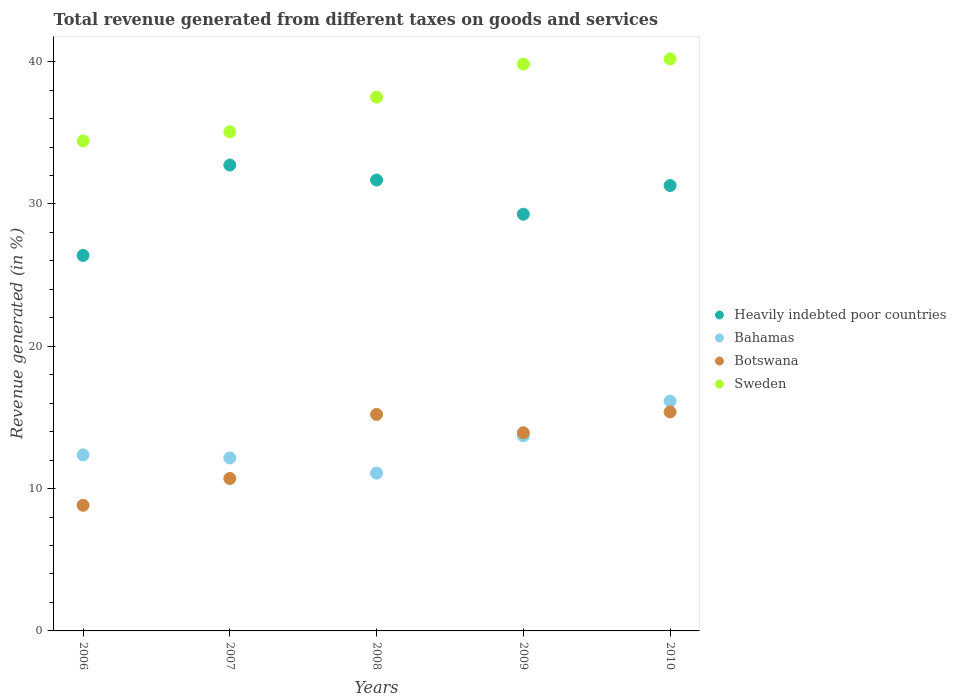How many different coloured dotlines are there?
Give a very brief answer. 4. Is the number of dotlines equal to the number of legend labels?
Make the answer very short. Yes. What is the total revenue generated in Botswana in 2008?
Provide a short and direct response. 15.21. Across all years, what is the maximum total revenue generated in Heavily indebted poor countries?
Provide a short and direct response. 32.74. Across all years, what is the minimum total revenue generated in Sweden?
Your answer should be compact. 34.43. What is the total total revenue generated in Botswana in the graph?
Keep it short and to the point. 64.07. What is the difference between the total revenue generated in Sweden in 2006 and that in 2010?
Provide a short and direct response. -5.76. What is the difference between the total revenue generated in Sweden in 2006 and the total revenue generated in Heavily indebted poor countries in 2009?
Provide a succinct answer. 5.15. What is the average total revenue generated in Sweden per year?
Your answer should be very brief. 37.41. In the year 2010, what is the difference between the total revenue generated in Sweden and total revenue generated in Bahamas?
Provide a succinct answer. 24.05. In how many years, is the total revenue generated in Botswana greater than 2 %?
Give a very brief answer. 5. What is the ratio of the total revenue generated in Sweden in 2007 to that in 2009?
Provide a short and direct response. 0.88. What is the difference between the highest and the second highest total revenue generated in Sweden?
Your answer should be compact. 0.37. What is the difference between the highest and the lowest total revenue generated in Sweden?
Provide a short and direct response. 5.76. In how many years, is the total revenue generated in Botswana greater than the average total revenue generated in Botswana taken over all years?
Provide a short and direct response. 3. Is the sum of the total revenue generated in Sweden in 2006 and 2007 greater than the maximum total revenue generated in Heavily indebted poor countries across all years?
Ensure brevity in your answer.  Yes. Is it the case that in every year, the sum of the total revenue generated in Heavily indebted poor countries and total revenue generated in Bahamas  is greater than the sum of total revenue generated in Botswana and total revenue generated in Sweden?
Your response must be concise. Yes. Is it the case that in every year, the sum of the total revenue generated in Sweden and total revenue generated in Heavily indebted poor countries  is greater than the total revenue generated in Botswana?
Offer a terse response. Yes. Does the total revenue generated in Heavily indebted poor countries monotonically increase over the years?
Offer a terse response. No. How many years are there in the graph?
Make the answer very short. 5. Does the graph contain any zero values?
Your response must be concise. No. Does the graph contain grids?
Your answer should be very brief. No. Where does the legend appear in the graph?
Keep it short and to the point. Center right. What is the title of the graph?
Offer a terse response. Total revenue generated from different taxes on goods and services. What is the label or title of the Y-axis?
Offer a terse response. Revenue generated (in %). What is the Revenue generated (in %) of Heavily indebted poor countries in 2006?
Provide a succinct answer. 26.38. What is the Revenue generated (in %) in Bahamas in 2006?
Offer a terse response. 12.37. What is the Revenue generated (in %) in Botswana in 2006?
Keep it short and to the point. 8.83. What is the Revenue generated (in %) in Sweden in 2006?
Your answer should be compact. 34.43. What is the Revenue generated (in %) in Heavily indebted poor countries in 2007?
Your answer should be compact. 32.74. What is the Revenue generated (in %) of Bahamas in 2007?
Provide a short and direct response. 12.16. What is the Revenue generated (in %) in Botswana in 2007?
Ensure brevity in your answer.  10.71. What is the Revenue generated (in %) of Sweden in 2007?
Give a very brief answer. 35.07. What is the Revenue generated (in %) in Heavily indebted poor countries in 2008?
Keep it short and to the point. 31.68. What is the Revenue generated (in %) in Bahamas in 2008?
Ensure brevity in your answer.  11.09. What is the Revenue generated (in %) of Botswana in 2008?
Your response must be concise. 15.21. What is the Revenue generated (in %) in Sweden in 2008?
Give a very brief answer. 37.51. What is the Revenue generated (in %) of Heavily indebted poor countries in 2009?
Offer a terse response. 29.28. What is the Revenue generated (in %) in Bahamas in 2009?
Give a very brief answer. 13.71. What is the Revenue generated (in %) of Botswana in 2009?
Provide a succinct answer. 13.92. What is the Revenue generated (in %) of Sweden in 2009?
Offer a very short reply. 39.83. What is the Revenue generated (in %) in Heavily indebted poor countries in 2010?
Provide a succinct answer. 31.3. What is the Revenue generated (in %) in Bahamas in 2010?
Ensure brevity in your answer.  16.15. What is the Revenue generated (in %) in Botswana in 2010?
Your response must be concise. 15.39. What is the Revenue generated (in %) in Sweden in 2010?
Your answer should be compact. 40.2. Across all years, what is the maximum Revenue generated (in %) in Heavily indebted poor countries?
Your answer should be compact. 32.74. Across all years, what is the maximum Revenue generated (in %) of Bahamas?
Keep it short and to the point. 16.15. Across all years, what is the maximum Revenue generated (in %) in Botswana?
Provide a succinct answer. 15.39. Across all years, what is the maximum Revenue generated (in %) of Sweden?
Give a very brief answer. 40.2. Across all years, what is the minimum Revenue generated (in %) in Heavily indebted poor countries?
Provide a succinct answer. 26.38. Across all years, what is the minimum Revenue generated (in %) in Bahamas?
Your answer should be very brief. 11.09. Across all years, what is the minimum Revenue generated (in %) of Botswana?
Give a very brief answer. 8.83. Across all years, what is the minimum Revenue generated (in %) in Sweden?
Give a very brief answer. 34.43. What is the total Revenue generated (in %) in Heavily indebted poor countries in the graph?
Your answer should be very brief. 151.38. What is the total Revenue generated (in %) in Bahamas in the graph?
Your answer should be very brief. 65.47. What is the total Revenue generated (in %) in Botswana in the graph?
Your response must be concise. 64.07. What is the total Revenue generated (in %) of Sweden in the graph?
Make the answer very short. 187.04. What is the difference between the Revenue generated (in %) of Heavily indebted poor countries in 2006 and that in 2007?
Your answer should be compact. -6.35. What is the difference between the Revenue generated (in %) of Bahamas in 2006 and that in 2007?
Provide a succinct answer. 0.21. What is the difference between the Revenue generated (in %) in Botswana in 2006 and that in 2007?
Your answer should be compact. -1.88. What is the difference between the Revenue generated (in %) in Sweden in 2006 and that in 2007?
Make the answer very short. -0.64. What is the difference between the Revenue generated (in %) of Heavily indebted poor countries in 2006 and that in 2008?
Make the answer very short. -5.3. What is the difference between the Revenue generated (in %) in Bahamas in 2006 and that in 2008?
Your answer should be compact. 1.28. What is the difference between the Revenue generated (in %) in Botswana in 2006 and that in 2008?
Offer a terse response. -6.38. What is the difference between the Revenue generated (in %) in Sweden in 2006 and that in 2008?
Your response must be concise. -3.07. What is the difference between the Revenue generated (in %) of Heavily indebted poor countries in 2006 and that in 2009?
Offer a terse response. -2.9. What is the difference between the Revenue generated (in %) of Bahamas in 2006 and that in 2009?
Offer a very short reply. -1.34. What is the difference between the Revenue generated (in %) in Botswana in 2006 and that in 2009?
Make the answer very short. -5.09. What is the difference between the Revenue generated (in %) in Sweden in 2006 and that in 2009?
Your response must be concise. -5.39. What is the difference between the Revenue generated (in %) in Heavily indebted poor countries in 2006 and that in 2010?
Offer a very short reply. -4.91. What is the difference between the Revenue generated (in %) in Bahamas in 2006 and that in 2010?
Your answer should be very brief. -3.78. What is the difference between the Revenue generated (in %) in Botswana in 2006 and that in 2010?
Your response must be concise. -6.56. What is the difference between the Revenue generated (in %) of Sweden in 2006 and that in 2010?
Offer a very short reply. -5.76. What is the difference between the Revenue generated (in %) of Heavily indebted poor countries in 2007 and that in 2008?
Provide a short and direct response. 1.05. What is the difference between the Revenue generated (in %) in Bahamas in 2007 and that in 2008?
Keep it short and to the point. 1.07. What is the difference between the Revenue generated (in %) in Botswana in 2007 and that in 2008?
Keep it short and to the point. -4.5. What is the difference between the Revenue generated (in %) in Sweden in 2007 and that in 2008?
Offer a very short reply. -2.44. What is the difference between the Revenue generated (in %) of Heavily indebted poor countries in 2007 and that in 2009?
Ensure brevity in your answer.  3.46. What is the difference between the Revenue generated (in %) of Bahamas in 2007 and that in 2009?
Your response must be concise. -1.55. What is the difference between the Revenue generated (in %) in Botswana in 2007 and that in 2009?
Your response must be concise. -3.21. What is the difference between the Revenue generated (in %) in Sweden in 2007 and that in 2009?
Offer a very short reply. -4.76. What is the difference between the Revenue generated (in %) in Heavily indebted poor countries in 2007 and that in 2010?
Your answer should be compact. 1.44. What is the difference between the Revenue generated (in %) in Bahamas in 2007 and that in 2010?
Offer a very short reply. -3.99. What is the difference between the Revenue generated (in %) of Botswana in 2007 and that in 2010?
Keep it short and to the point. -4.68. What is the difference between the Revenue generated (in %) of Sweden in 2007 and that in 2010?
Ensure brevity in your answer.  -5.12. What is the difference between the Revenue generated (in %) in Heavily indebted poor countries in 2008 and that in 2009?
Give a very brief answer. 2.4. What is the difference between the Revenue generated (in %) in Bahamas in 2008 and that in 2009?
Offer a very short reply. -2.62. What is the difference between the Revenue generated (in %) in Botswana in 2008 and that in 2009?
Your answer should be very brief. 1.29. What is the difference between the Revenue generated (in %) of Sweden in 2008 and that in 2009?
Make the answer very short. -2.32. What is the difference between the Revenue generated (in %) in Heavily indebted poor countries in 2008 and that in 2010?
Provide a short and direct response. 0.39. What is the difference between the Revenue generated (in %) of Bahamas in 2008 and that in 2010?
Offer a terse response. -5.06. What is the difference between the Revenue generated (in %) in Botswana in 2008 and that in 2010?
Offer a very short reply. -0.17. What is the difference between the Revenue generated (in %) of Sweden in 2008 and that in 2010?
Offer a terse response. -2.69. What is the difference between the Revenue generated (in %) of Heavily indebted poor countries in 2009 and that in 2010?
Keep it short and to the point. -2.02. What is the difference between the Revenue generated (in %) in Bahamas in 2009 and that in 2010?
Offer a very short reply. -2.44. What is the difference between the Revenue generated (in %) of Botswana in 2009 and that in 2010?
Provide a short and direct response. -1.46. What is the difference between the Revenue generated (in %) of Sweden in 2009 and that in 2010?
Provide a short and direct response. -0.37. What is the difference between the Revenue generated (in %) of Heavily indebted poor countries in 2006 and the Revenue generated (in %) of Bahamas in 2007?
Offer a very short reply. 14.23. What is the difference between the Revenue generated (in %) in Heavily indebted poor countries in 2006 and the Revenue generated (in %) in Botswana in 2007?
Offer a terse response. 15.67. What is the difference between the Revenue generated (in %) of Heavily indebted poor countries in 2006 and the Revenue generated (in %) of Sweden in 2007?
Ensure brevity in your answer.  -8.69. What is the difference between the Revenue generated (in %) in Bahamas in 2006 and the Revenue generated (in %) in Botswana in 2007?
Offer a very short reply. 1.66. What is the difference between the Revenue generated (in %) in Bahamas in 2006 and the Revenue generated (in %) in Sweden in 2007?
Your answer should be compact. -22.7. What is the difference between the Revenue generated (in %) in Botswana in 2006 and the Revenue generated (in %) in Sweden in 2007?
Offer a terse response. -26.24. What is the difference between the Revenue generated (in %) of Heavily indebted poor countries in 2006 and the Revenue generated (in %) of Bahamas in 2008?
Give a very brief answer. 15.3. What is the difference between the Revenue generated (in %) of Heavily indebted poor countries in 2006 and the Revenue generated (in %) of Botswana in 2008?
Keep it short and to the point. 11.17. What is the difference between the Revenue generated (in %) in Heavily indebted poor countries in 2006 and the Revenue generated (in %) in Sweden in 2008?
Ensure brevity in your answer.  -11.12. What is the difference between the Revenue generated (in %) of Bahamas in 2006 and the Revenue generated (in %) of Botswana in 2008?
Provide a short and direct response. -2.84. What is the difference between the Revenue generated (in %) in Bahamas in 2006 and the Revenue generated (in %) in Sweden in 2008?
Offer a terse response. -25.14. What is the difference between the Revenue generated (in %) in Botswana in 2006 and the Revenue generated (in %) in Sweden in 2008?
Offer a terse response. -28.68. What is the difference between the Revenue generated (in %) in Heavily indebted poor countries in 2006 and the Revenue generated (in %) in Bahamas in 2009?
Make the answer very short. 12.68. What is the difference between the Revenue generated (in %) of Heavily indebted poor countries in 2006 and the Revenue generated (in %) of Botswana in 2009?
Provide a succinct answer. 12.46. What is the difference between the Revenue generated (in %) in Heavily indebted poor countries in 2006 and the Revenue generated (in %) in Sweden in 2009?
Your response must be concise. -13.44. What is the difference between the Revenue generated (in %) of Bahamas in 2006 and the Revenue generated (in %) of Botswana in 2009?
Your response must be concise. -1.55. What is the difference between the Revenue generated (in %) of Bahamas in 2006 and the Revenue generated (in %) of Sweden in 2009?
Make the answer very short. -27.46. What is the difference between the Revenue generated (in %) in Botswana in 2006 and the Revenue generated (in %) in Sweden in 2009?
Keep it short and to the point. -31. What is the difference between the Revenue generated (in %) of Heavily indebted poor countries in 2006 and the Revenue generated (in %) of Bahamas in 2010?
Offer a very short reply. 10.24. What is the difference between the Revenue generated (in %) of Heavily indebted poor countries in 2006 and the Revenue generated (in %) of Botswana in 2010?
Your answer should be very brief. 11. What is the difference between the Revenue generated (in %) of Heavily indebted poor countries in 2006 and the Revenue generated (in %) of Sweden in 2010?
Offer a terse response. -13.81. What is the difference between the Revenue generated (in %) in Bahamas in 2006 and the Revenue generated (in %) in Botswana in 2010?
Give a very brief answer. -3.02. What is the difference between the Revenue generated (in %) in Bahamas in 2006 and the Revenue generated (in %) in Sweden in 2010?
Keep it short and to the point. -27.83. What is the difference between the Revenue generated (in %) in Botswana in 2006 and the Revenue generated (in %) in Sweden in 2010?
Offer a terse response. -31.37. What is the difference between the Revenue generated (in %) in Heavily indebted poor countries in 2007 and the Revenue generated (in %) in Bahamas in 2008?
Your response must be concise. 21.65. What is the difference between the Revenue generated (in %) of Heavily indebted poor countries in 2007 and the Revenue generated (in %) of Botswana in 2008?
Provide a short and direct response. 17.52. What is the difference between the Revenue generated (in %) of Heavily indebted poor countries in 2007 and the Revenue generated (in %) of Sweden in 2008?
Provide a succinct answer. -4.77. What is the difference between the Revenue generated (in %) of Bahamas in 2007 and the Revenue generated (in %) of Botswana in 2008?
Your answer should be compact. -3.06. What is the difference between the Revenue generated (in %) of Bahamas in 2007 and the Revenue generated (in %) of Sweden in 2008?
Your response must be concise. -25.35. What is the difference between the Revenue generated (in %) of Botswana in 2007 and the Revenue generated (in %) of Sweden in 2008?
Your answer should be compact. -26.8. What is the difference between the Revenue generated (in %) of Heavily indebted poor countries in 2007 and the Revenue generated (in %) of Bahamas in 2009?
Ensure brevity in your answer.  19.03. What is the difference between the Revenue generated (in %) of Heavily indebted poor countries in 2007 and the Revenue generated (in %) of Botswana in 2009?
Make the answer very short. 18.81. What is the difference between the Revenue generated (in %) in Heavily indebted poor countries in 2007 and the Revenue generated (in %) in Sweden in 2009?
Offer a very short reply. -7.09. What is the difference between the Revenue generated (in %) of Bahamas in 2007 and the Revenue generated (in %) of Botswana in 2009?
Offer a terse response. -1.77. What is the difference between the Revenue generated (in %) of Bahamas in 2007 and the Revenue generated (in %) of Sweden in 2009?
Provide a short and direct response. -27.67. What is the difference between the Revenue generated (in %) of Botswana in 2007 and the Revenue generated (in %) of Sweden in 2009?
Make the answer very short. -29.12. What is the difference between the Revenue generated (in %) of Heavily indebted poor countries in 2007 and the Revenue generated (in %) of Bahamas in 2010?
Make the answer very short. 16.59. What is the difference between the Revenue generated (in %) of Heavily indebted poor countries in 2007 and the Revenue generated (in %) of Botswana in 2010?
Make the answer very short. 17.35. What is the difference between the Revenue generated (in %) of Heavily indebted poor countries in 2007 and the Revenue generated (in %) of Sweden in 2010?
Give a very brief answer. -7.46. What is the difference between the Revenue generated (in %) in Bahamas in 2007 and the Revenue generated (in %) in Botswana in 2010?
Your response must be concise. -3.23. What is the difference between the Revenue generated (in %) in Bahamas in 2007 and the Revenue generated (in %) in Sweden in 2010?
Provide a short and direct response. -28.04. What is the difference between the Revenue generated (in %) of Botswana in 2007 and the Revenue generated (in %) of Sweden in 2010?
Your answer should be compact. -29.48. What is the difference between the Revenue generated (in %) of Heavily indebted poor countries in 2008 and the Revenue generated (in %) of Bahamas in 2009?
Give a very brief answer. 17.97. What is the difference between the Revenue generated (in %) in Heavily indebted poor countries in 2008 and the Revenue generated (in %) in Botswana in 2009?
Keep it short and to the point. 17.76. What is the difference between the Revenue generated (in %) in Heavily indebted poor countries in 2008 and the Revenue generated (in %) in Sweden in 2009?
Keep it short and to the point. -8.15. What is the difference between the Revenue generated (in %) of Bahamas in 2008 and the Revenue generated (in %) of Botswana in 2009?
Your answer should be compact. -2.84. What is the difference between the Revenue generated (in %) in Bahamas in 2008 and the Revenue generated (in %) in Sweden in 2009?
Ensure brevity in your answer.  -28.74. What is the difference between the Revenue generated (in %) in Botswana in 2008 and the Revenue generated (in %) in Sweden in 2009?
Provide a succinct answer. -24.62. What is the difference between the Revenue generated (in %) of Heavily indebted poor countries in 2008 and the Revenue generated (in %) of Bahamas in 2010?
Give a very brief answer. 15.54. What is the difference between the Revenue generated (in %) of Heavily indebted poor countries in 2008 and the Revenue generated (in %) of Botswana in 2010?
Your answer should be very brief. 16.3. What is the difference between the Revenue generated (in %) in Heavily indebted poor countries in 2008 and the Revenue generated (in %) in Sweden in 2010?
Your response must be concise. -8.51. What is the difference between the Revenue generated (in %) in Bahamas in 2008 and the Revenue generated (in %) in Botswana in 2010?
Keep it short and to the point. -4.3. What is the difference between the Revenue generated (in %) in Bahamas in 2008 and the Revenue generated (in %) in Sweden in 2010?
Make the answer very short. -29.11. What is the difference between the Revenue generated (in %) in Botswana in 2008 and the Revenue generated (in %) in Sweden in 2010?
Your response must be concise. -24.98. What is the difference between the Revenue generated (in %) in Heavily indebted poor countries in 2009 and the Revenue generated (in %) in Bahamas in 2010?
Your response must be concise. 13.13. What is the difference between the Revenue generated (in %) of Heavily indebted poor countries in 2009 and the Revenue generated (in %) of Botswana in 2010?
Offer a very short reply. 13.89. What is the difference between the Revenue generated (in %) of Heavily indebted poor countries in 2009 and the Revenue generated (in %) of Sweden in 2010?
Your answer should be compact. -10.91. What is the difference between the Revenue generated (in %) in Bahamas in 2009 and the Revenue generated (in %) in Botswana in 2010?
Ensure brevity in your answer.  -1.68. What is the difference between the Revenue generated (in %) in Bahamas in 2009 and the Revenue generated (in %) in Sweden in 2010?
Your answer should be compact. -26.49. What is the difference between the Revenue generated (in %) of Botswana in 2009 and the Revenue generated (in %) of Sweden in 2010?
Your answer should be compact. -26.27. What is the average Revenue generated (in %) in Heavily indebted poor countries per year?
Ensure brevity in your answer.  30.28. What is the average Revenue generated (in %) of Bahamas per year?
Give a very brief answer. 13.09. What is the average Revenue generated (in %) in Botswana per year?
Make the answer very short. 12.81. What is the average Revenue generated (in %) of Sweden per year?
Ensure brevity in your answer.  37.41. In the year 2006, what is the difference between the Revenue generated (in %) of Heavily indebted poor countries and Revenue generated (in %) of Bahamas?
Provide a succinct answer. 14.02. In the year 2006, what is the difference between the Revenue generated (in %) of Heavily indebted poor countries and Revenue generated (in %) of Botswana?
Make the answer very short. 17.56. In the year 2006, what is the difference between the Revenue generated (in %) in Heavily indebted poor countries and Revenue generated (in %) in Sweden?
Ensure brevity in your answer.  -8.05. In the year 2006, what is the difference between the Revenue generated (in %) in Bahamas and Revenue generated (in %) in Botswana?
Keep it short and to the point. 3.54. In the year 2006, what is the difference between the Revenue generated (in %) in Bahamas and Revenue generated (in %) in Sweden?
Make the answer very short. -22.06. In the year 2006, what is the difference between the Revenue generated (in %) in Botswana and Revenue generated (in %) in Sweden?
Your answer should be compact. -25.61. In the year 2007, what is the difference between the Revenue generated (in %) in Heavily indebted poor countries and Revenue generated (in %) in Bahamas?
Offer a terse response. 20.58. In the year 2007, what is the difference between the Revenue generated (in %) of Heavily indebted poor countries and Revenue generated (in %) of Botswana?
Keep it short and to the point. 22.03. In the year 2007, what is the difference between the Revenue generated (in %) of Heavily indebted poor countries and Revenue generated (in %) of Sweden?
Provide a succinct answer. -2.33. In the year 2007, what is the difference between the Revenue generated (in %) in Bahamas and Revenue generated (in %) in Botswana?
Offer a very short reply. 1.44. In the year 2007, what is the difference between the Revenue generated (in %) in Bahamas and Revenue generated (in %) in Sweden?
Offer a very short reply. -22.92. In the year 2007, what is the difference between the Revenue generated (in %) of Botswana and Revenue generated (in %) of Sweden?
Your answer should be very brief. -24.36. In the year 2008, what is the difference between the Revenue generated (in %) in Heavily indebted poor countries and Revenue generated (in %) in Bahamas?
Offer a very short reply. 20.6. In the year 2008, what is the difference between the Revenue generated (in %) in Heavily indebted poor countries and Revenue generated (in %) in Botswana?
Keep it short and to the point. 16.47. In the year 2008, what is the difference between the Revenue generated (in %) in Heavily indebted poor countries and Revenue generated (in %) in Sweden?
Your response must be concise. -5.83. In the year 2008, what is the difference between the Revenue generated (in %) in Bahamas and Revenue generated (in %) in Botswana?
Keep it short and to the point. -4.13. In the year 2008, what is the difference between the Revenue generated (in %) of Bahamas and Revenue generated (in %) of Sweden?
Your answer should be very brief. -26.42. In the year 2008, what is the difference between the Revenue generated (in %) in Botswana and Revenue generated (in %) in Sweden?
Your response must be concise. -22.29. In the year 2009, what is the difference between the Revenue generated (in %) of Heavily indebted poor countries and Revenue generated (in %) of Bahamas?
Provide a succinct answer. 15.57. In the year 2009, what is the difference between the Revenue generated (in %) of Heavily indebted poor countries and Revenue generated (in %) of Botswana?
Offer a terse response. 15.36. In the year 2009, what is the difference between the Revenue generated (in %) of Heavily indebted poor countries and Revenue generated (in %) of Sweden?
Your answer should be compact. -10.55. In the year 2009, what is the difference between the Revenue generated (in %) of Bahamas and Revenue generated (in %) of Botswana?
Your answer should be compact. -0.21. In the year 2009, what is the difference between the Revenue generated (in %) of Bahamas and Revenue generated (in %) of Sweden?
Offer a terse response. -26.12. In the year 2009, what is the difference between the Revenue generated (in %) in Botswana and Revenue generated (in %) in Sweden?
Provide a short and direct response. -25.91. In the year 2010, what is the difference between the Revenue generated (in %) of Heavily indebted poor countries and Revenue generated (in %) of Bahamas?
Your answer should be compact. 15.15. In the year 2010, what is the difference between the Revenue generated (in %) in Heavily indebted poor countries and Revenue generated (in %) in Botswana?
Make the answer very short. 15.91. In the year 2010, what is the difference between the Revenue generated (in %) in Heavily indebted poor countries and Revenue generated (in %) in Sweden?
Keep it short and to the point. -8.9. In the year 2010, what is the difference between the Revenue generated (in %) in Bahamas and Revenue generated (in %) in Botswana?
Offer a terse response. 0.76. In the year 2010, what is the difference between the Revenue generated (in %) of Bahamas and Revenue generated (in %) of Sweden?
Your response must be concise. -24.05. In the year 2010, what is the difference between the Revenue generated (in %) of Botswana and Revenue generated (in %) of Sweden?
Your answer should be compact. -24.81. What is the ratio of the Revenue generated (in %) of Heavily indebted poor countries in 2006 to that in 2007?
Offer a terse response. 0.81. What is the ratio of the Revenue generated (in %) of Bahamas in 2006 to that in 2007?
Make the answer very short. 1.02. What is the ratio of the Revenue generated (in %) in Botswana in 2006 to that in 2007?
Give a very brief answer. 0.82. What is the ratio of the Revenue generated (in %) of Sweden in 2006 to that in 2007?
Make the answer very short. 0.98. What is the ratio of the Revenue generated (in %) of Heavily indebted poor countries in 2006 to that in 2008?
Your answer should be compact. 0.83. What is the ratio of the Revenue generated (in %) of Bahamas in 2006 to that in 2008?
Make the answer very short. 1.12. What is the ratio of the Revenue generated (in %) of Botswana in 2006 to that in 2008?
Your answer should be compact. 0.58. What is the ratio of the Revenue generated (in %) of Sweden in 2006 to that in 2008?
Your answer should be very brief. 0.92. What is the ratio of the Revenue generated (in %) in Heavily indebted poor countries in 2006 to that in 2009?
Give a very brief answer. 0.9. What is the ratio of the Revenue generated (in %) of Bahamas in 2006 to that in 2009?
Your answer should be compact. 0.9. What is the ratio of the Revenue generated (in %) of Botswana in 2006 to that in 2009?
Your answer should be compact. 0.63. What is the ratio of the Revenue generated (in %) of Sweden in 2006 to that in 2009?
Your answer should be very brief. 0.86. What is the ratio of the Revenue generated (in %) in Heavily indebted poor countries in 2006 to that in 2010?
Your answer should be very brief. 0.84. What is the ratio of the Revenue generated (in %) of Bahamas in 2006 to that in 2010?
Provide a short and direct response. 0.77. What is the ratio of the Revenue generated (in %) in Botswana in 2006 to that in 2010?
Make the answer very short. 0.57. What is the ratio of the Revenue generated (in %) of Sweden in 2006 to that in 2010?
Your answer should be very brief. 0.86. What is the ratio of the Revenue generated (in %) of Bahamas in 2007 to that in 2008?
Your answer should be very brief. 1.1. What is the ratio of the Revenue generated (in %) of Botswana in 2007 to that in 2008?
Offer a very short reply. 0.7. What is the ratio of the Revenue generated (in %) of Sweden in 2007 to that in 2008?
Keep it short and to the point. 0.94. What is the ratio of the Revenue generated (in %) of Heavily indebted poor countries in 2007 to that in 2009?
Your answer should be compact. 1.12. What is the ratio of the Revenue generated (in %) in Bahamas in 2007 to that in 2009?
Your answer should be very brief. 0.89. What is the ratio of the Revenue generated (in %) in Botswana in 2007 to that in 2009?
Provide a short and direct response. 0.77. What is the ratio of the Revenue generated (in %) of Sweden in 2007 to that in 2009?
Your answer should be very brief. 0.88. What is the ratio of the Revenue generated (in %) of Heavily indebted poor countries in 2007 to that in 2010?
Give a very brief answer. 1.05. What is the ratio of the Revenue generated (in %) of Bahamas in 2007 to that in 2010?
Keep it short and to the point. 0.75. What is the ratio of the Revenue generated (in %) in Botswana in 2007 to that in 2010?
Make the answer very short. 0.7. What is the ratio of the Revenue generated (in %) of Sweden in 2007 to that in 2010?
Your response must be concise. 0.87. What is the ratio of the Revenue generated (in %) of Heavily indebted poor countries in 2008 to that in 2009?
Provide a succinct answer. 1.08. What is the ratio of the Revenue generated (in %) of Bahamas in 2008 to that in 2009?
Your answer should be compact. 0.81. What is the ratio of the Revenue generated (in %) of Botswana in 2008 to that in 2009?
Your answer should be compact. 1.09. What is the ratio of the Revenue generated (in %) in Sweden in 2008 to that in 2009?
Offer a very short reply. 0.94. What is the ratio of the Revenue generated (in %) in Heavily indebted poor countries in 2008 to that in 2010?
Keep it short and to the point. 1.01. What is the ratio of the Revenue generated (in %) of Bahamas in 2008 to that in 2010?
Give a very brief answer. 0.69. What is the ratio of the Revenue generated (in %) in Botswana in 2008 to that in 2010?
Provide a succinct answer. 0.99. What is the ratio of the Revenue generated (in %) in Sweden in 2008 to that in 2010?
Provide a succinct answer. 0.93. What is the ratio of the Revenue generated (in %) of Heavily indebted poor countries in 2009 to that in 2010?
Provide a succinct answer. 0.94. What is the ratio of the Revenue generated (in %) of Bahamas in 2009 to that in 2010?
Give a very brief answer. 0.85. What is the ratio of the Revenue generated (in %) in Botswana in 2009 to that in 2010?
Provide a succinct answer. 0.9. What is the ratio of the Revenue generated (in %) in Sweden in 2009 to that in 2010?
Keep it short and to the point. 0.99. What is the difference between the highest and the second highest Revenue generated (in %) in Heavily indebted poor countries?
Your answer should be very brief. 1.05. What is the difference between the highest and the second highest Revenue generated (in %) of Bahamas?
Your answer should be compact. 2.44. What is the difference between the highest and the second highest Revenue generated (in %) of Botswana?
Provide a short and direct response. 0.17. What is the difference between the highest and the second highest Revenue generated (in %) in Sweden?
Offer a terse response. 0.37. What is the difference between the highest and the lowest Revenue generated (in %) of Heavily indebted poor countries?
Your answer should be compact. 6.35. What is the difference between the highest and the lowest Revenue generated (in %) of Bahamas?
Your response must be concise. 5.06. What is the difference between the highest and the lowest Revenue generated (in %) of Botswana?
Provide a short and direct response. 6.56. What is the difference between the highest and the lowest Revenue generated (in %) of Sweden?
Ensure brevity in your answer.  5.76. 